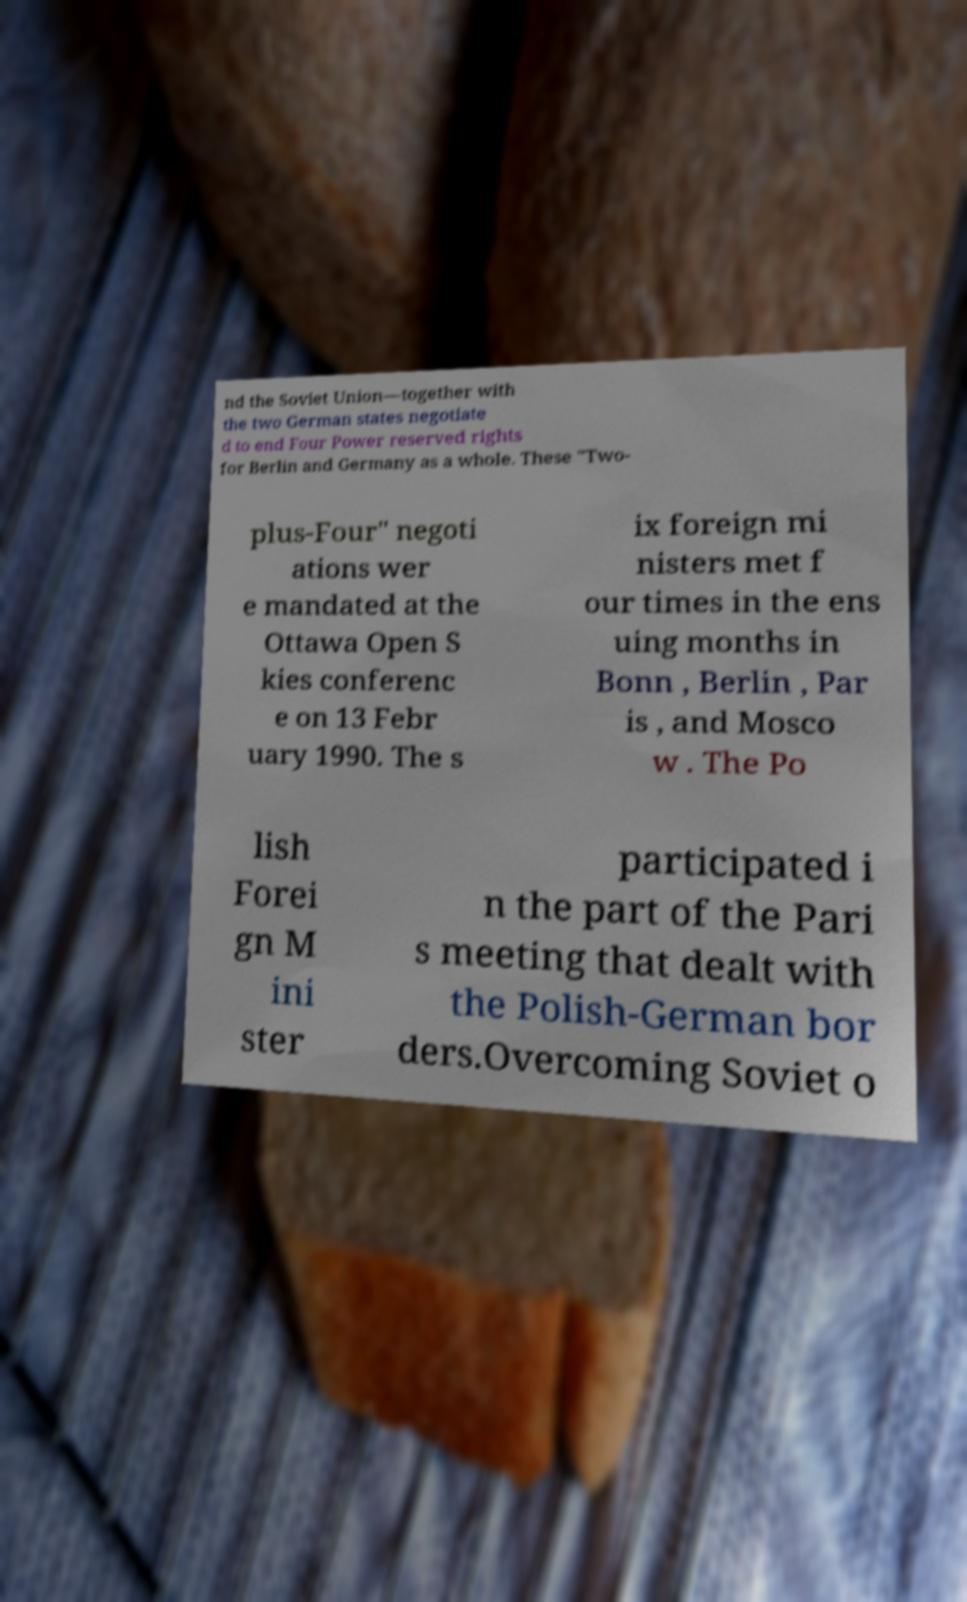Please identify and transcribe the text found in this image. nd the Soviet Union—together with the two German states negotiate d to end Four Power reserved rights for Berlin and Germany as a whole. These "Two- plus-Four" negoti ations wer e mandated at the Ottawa Open S kies conferenc e on 13 Febr uary 1990. The s ix foreign mi nisters met f our times in the ens uing months in Bonn , Berlin , Par is , and Mosco w . The Po lish Forei gn M ini ster participated i n the part of the Pari s meeting that dealt with the Polish-German bor ders.Overcoming Soviet o 